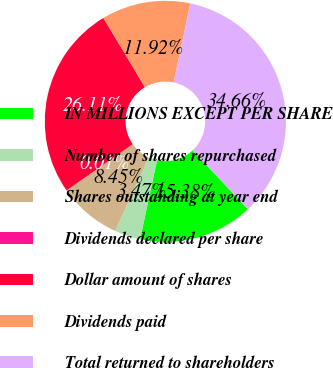<chart> <loc_0><loc_0><loc_500><loc_500><pie_chart><fcel>IN MILLIONS EXCEPT PER SHARE<fcel>Number of shares repurchased<fcel>Shares outstanding at year end<fcel>Dividends declared per share<fcel>Dollar amount of shares<fcel>Dividends paid<fcel>Total returned to shareholders<nl><fcel>15.38%<fcel>3.47%<fcel>8.45%<fcel>0.01%<fcel>26.11%<fcel>11.92%<fcel>34.66%<nl></chart> 